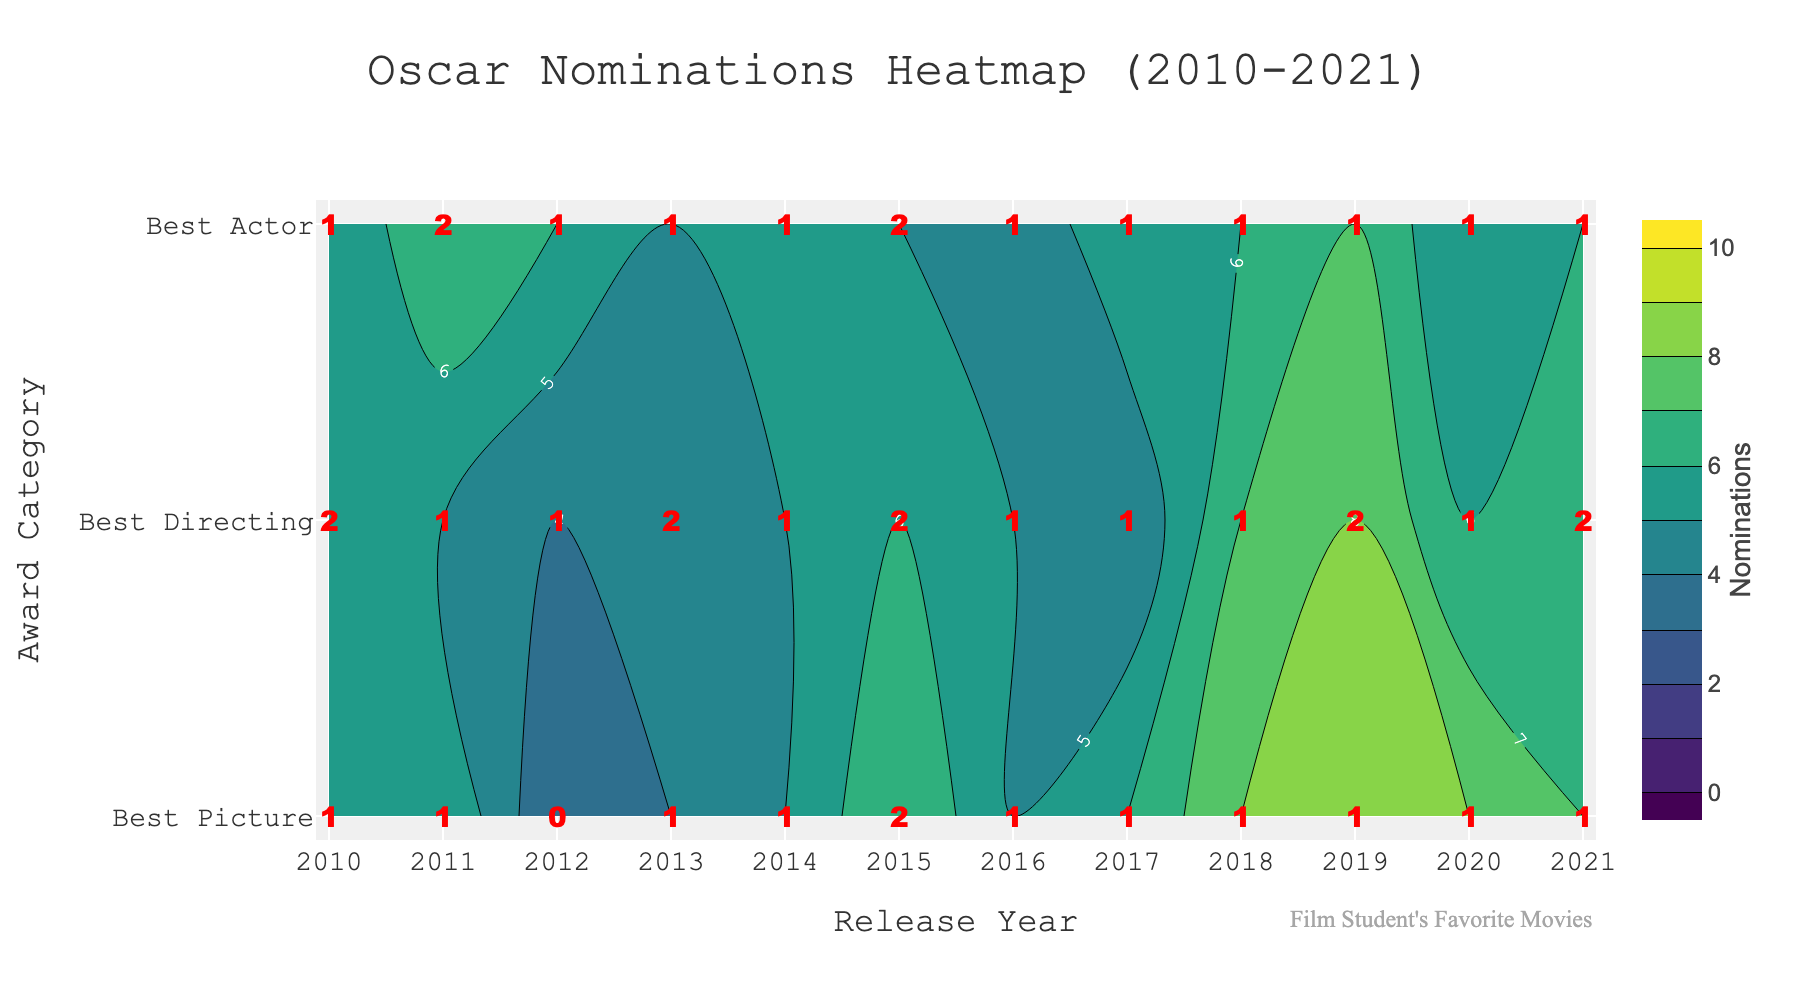How many award categories are shown in the contour plot? The y-axis of the contour plot shows the award categories. There are three categories labeled: Best Picture, Best Directing, and Best Actor.
Answer: 3 What is the title of the plot? The title of the plot is displayed at the top center of the figure. The title is "Oscar Nominations Heatmap (2010-2021)".
Answer: Oscar Nominations Heatmap (2010-2021) In which year did the Best Picture category receive the maximum nominations? By observing the 'Best Picture' row in the contour plot and looking for the highest value, you can see that the maximum nominations for Best Picture occurred in 2019 with a value of 9.
Answer: 2019 Which year had the highest number of Best Actor wins, and how many wins were there? Examining the annotations in the 'Best Actor' row, the highest number of wins is indicated by the number '2' in the year 2011 and 2015.
Answer: 2011 and 2015 with 2 wins each Compare the Best Directing nominations for the years 2015 and 2021. Which year had more nominations and by how much? Looking at the 'Best Directing' row in the contour plot, the nominations in 2015 are 6 and in 2021 are 7. 2021 had more nominations with a difference of 1.
Answer: 2021 by 1 How do the nominations for Best Picture trends compare to Best Actor nominations over the years 2010-2021? Observing the values along the 'Best Picture' and 'Best Actor' rows in the contour plot, both categories exhibit an increasing trend with some fluctuations. High nomination years for Best Picture (e.g., 2019) show peaks that generally align with high nomination years for Best Actor but not consistently in exact numbers.
Answer: Increasing trend with fluctuations What is the total number of Best Directing wins from 2010 to 2021? Summing up the annotations for the 'Best Directing' row over the years 2010 to 2021: 2 + 1 + 1 + 2 + 1 + 2 + 1 + 1 + 1 + 2 + 1 + 2 = 17.
Answer: 17 In what years did Best Picture and Best Directing both have at least 6 nominations? Identifying the years from the contour plot where both 'Best Picture' and 'Best Directing' rows are 6 or higher, the relevant years are found to be 2015 and 2019.
Answer: 2015 and 2019 